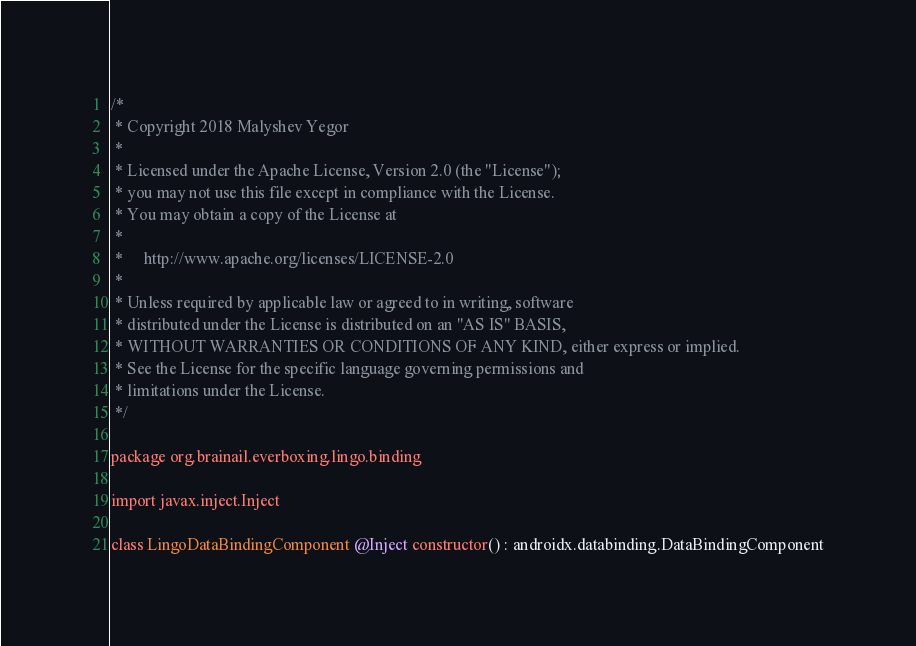<code> <loc_0><loc_0><loc_500><loc_500><_Kotlin_>/*
 * Copyright 2018 Malyshev Yegor
 *
 * Licensed under the Apache License, Version 2.0 (the "License");
 * you may not use this file except in compliance with the License.
 * You may obtain a copy of the License at
 *
 *     http://www.apache.org/licenses/LICENSE-2.0
 *
 * Unless required by applicable law or agreed to in writing, software
 * distributed under the License is distributed on an "AS IS" BASIS,
 * WITHOUT WARRANTIES OR CONDITIONS OF ANY KIND, either express or implied.
 * See the License for the specific language governing permissions and
 * limitations under the License.
 */

package org.brainail.everboxing.lingo.binding

import javax.inject.Inject

class LingoDataBindingComponent @Inject constructor() : androidx.databinding.DataBindingComponent
</code> 